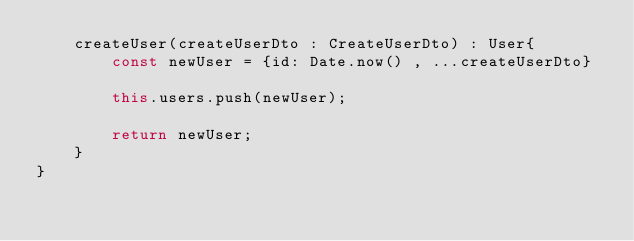<code> <loc_0><loc_0><loc_500><loc_500><_TypeScript_>    createUser(createUserDto : CreateUserDto) : User{
        const newUser = {id: Date.now() , ...createUserDto}

        this.users.push(newUser);

        return newUser;
    }
}
</code> 